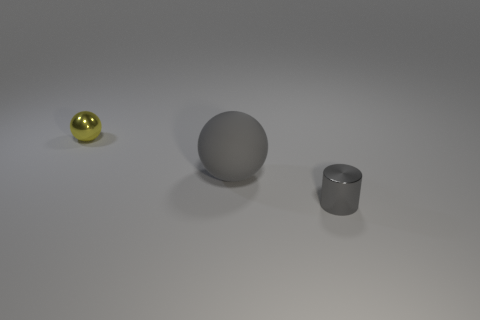Does the gray cylinder have the same material as the small yellow object?
Give a very brief answer. Yes. There is a object that is the same color as the shiny cylinder; what is it made of?
Offer a terse response. Rubber. What is the color of the small shiny sphere?
Provide a succinct answer. Yellow. There is a tiny shiny object that is in front of the tiny yellow sphere; is there a rubber ball that is behind it?
Your answer should be very brief. Yes. What material is the big thing?
Make the answer very short. Rubber. Do the tiny thing to the right of the yellow ball and the small object to the left of the gray cylinder have the same material?
Offer a very short reply. Yes. Are there any other things of the same color as the metal ball?
Offer a very short reply. No. What is the color of the tiny shiny object that is the same shape as the matte object?
Offer a terse response. Yellow. Do the gray rubber thing that is in front of the yellow shiny sphere and the metallic object that is on the left side of the small gray shiny cylinder have the same shape?
Provide a short and direct response. Yes. There is a small metallic thing that is the same color as the matte object; what is its shape?
Your answer should be very brief. Cylinder. 